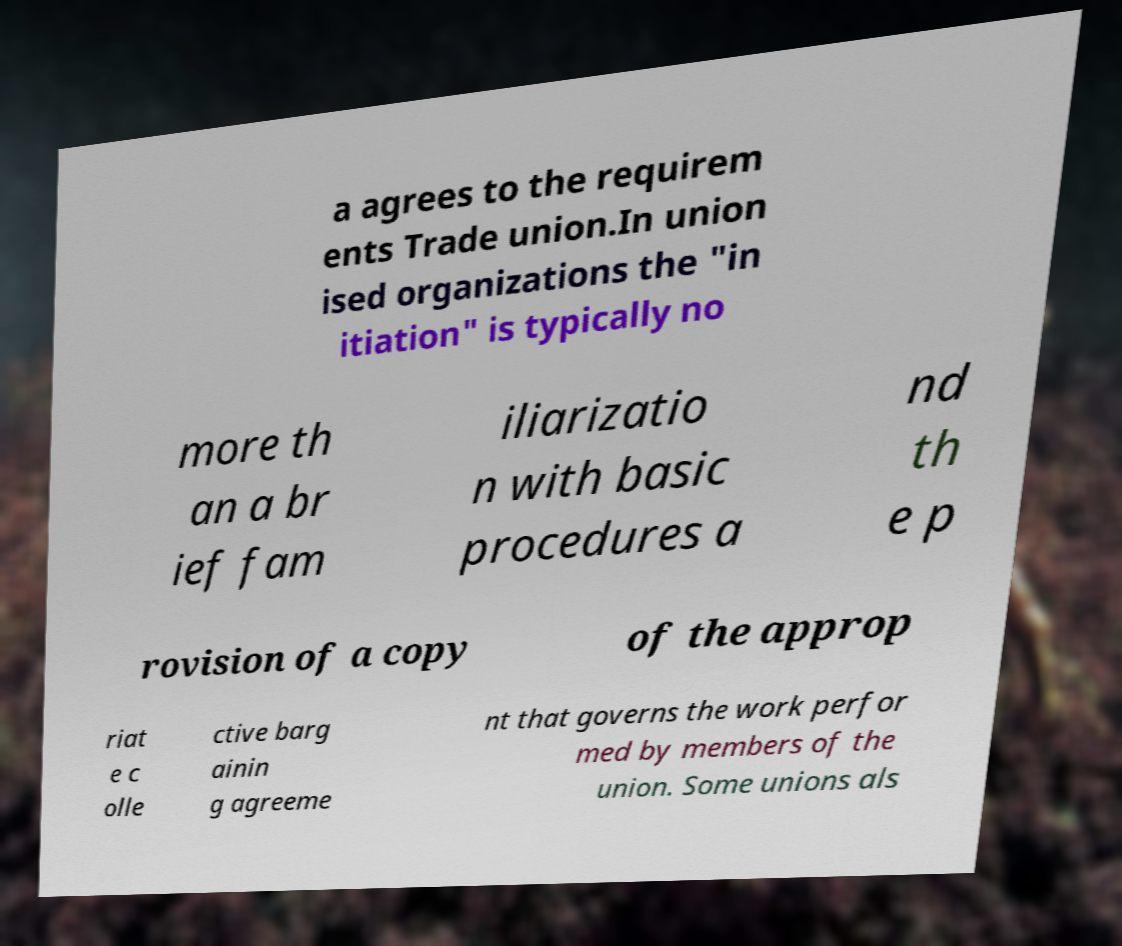I need the written content from this picture converted into text. Can you do that? a agrees to the requirem ents Trade union.In union ised organizations the "in itiation" is typically no more th an a br ief fam iliarizatio n with basic procedures a nd th e p rovision of a copy of the approp riat e c olle ctive barg ainin g agreeme nt that governs the work perfor med by members of the union. Some unions als 